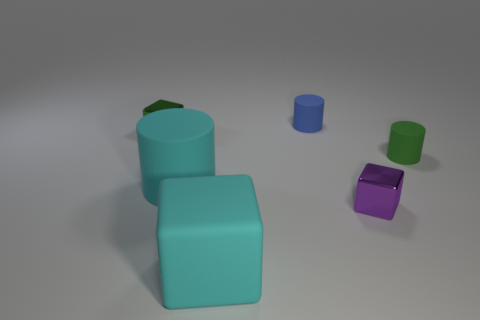What shape is the large matte thing behind the big cyan cube?
Keep it short and to the point. Cylinder. Are there any big rubber things left of the big cyan cylinder in front of the object left of the large cyan rubber cylinder?
Your response must be concise. No. There is a blue thing that is the same shape as the tiny green rubber object; what material is it?
Give a very brief answer. Rubber. Is there any other thing that is the same material as the small blue thing?
Offer a very short reply. Yes. How many spheres are cyan rubber things or tiny blue matte objects?
Make the answer very short. 0. There is a shiny object to the left of the blue rubber cylinder; is its size the same as the shiny thing in front of the green metallic object?
Provide a short and direct response. Yes. There is a small green object that is right of the cyan rubber thing right of the cyan cylinder; what is it made of?
Your response must be concise. Rubber. Is the number of small purple metal objects that are on the left side of the small purple cube less than the number of green objects?
Offer a terse response. Yes. There is a object that is the same material as the purple cube; what shape is it?
Provide a succinct answer. Cube. What number of other objects are the same shape as the purple object?
Offer a very short reply. 2. 